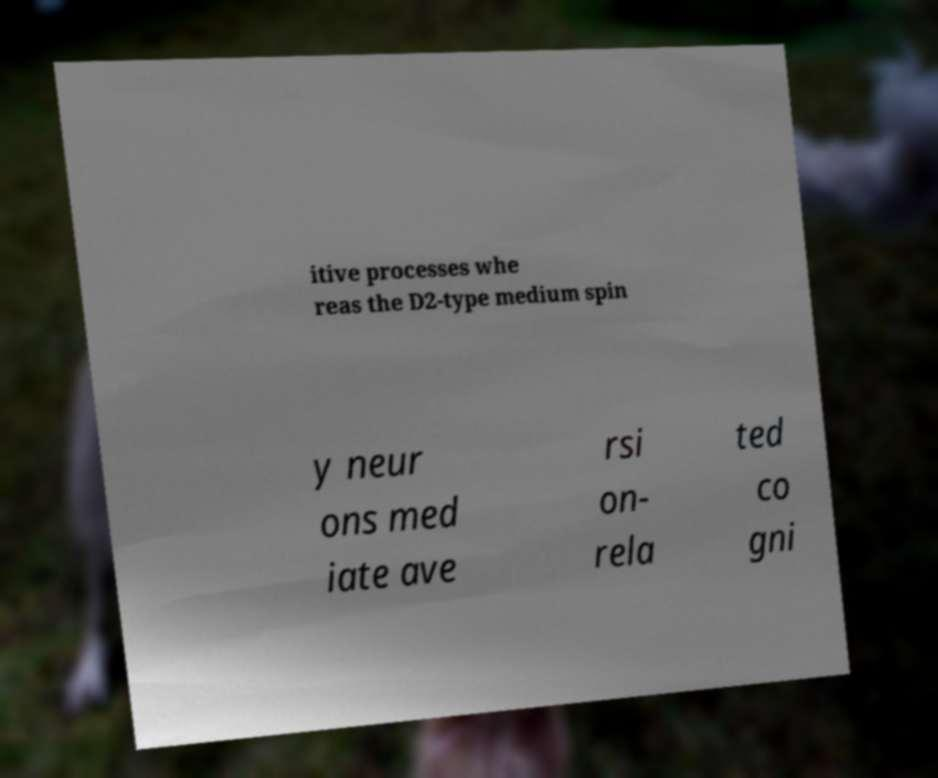For documentation purposes, I need the text within this image transcribed. Could you provide that? itive processes whe reas the D2-type medium spin y neur ons med iate ave rsi on- rela ted co gni 